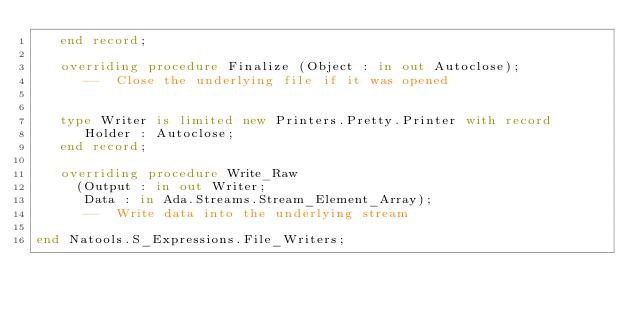Convert code to text. <code><loc_0><loc_0><loc_500><loc_500><_Ada_>   end record;

   overriding procedure Finalize (Object : in out Autoclose);
      --  Close the underlying file if it was opened


   type Writer is limited new Printers.Pretty.Printer with record
      Holder : Autoclose;
   end record;

   overriding procedure Write_Raw
     (Output : in out Writer;
      Data : in Ada.Streams.Stream_Element_Array);
      --  Write data into the underlying stream

end Natools.S_Expressions.File_Writers;
</code> 